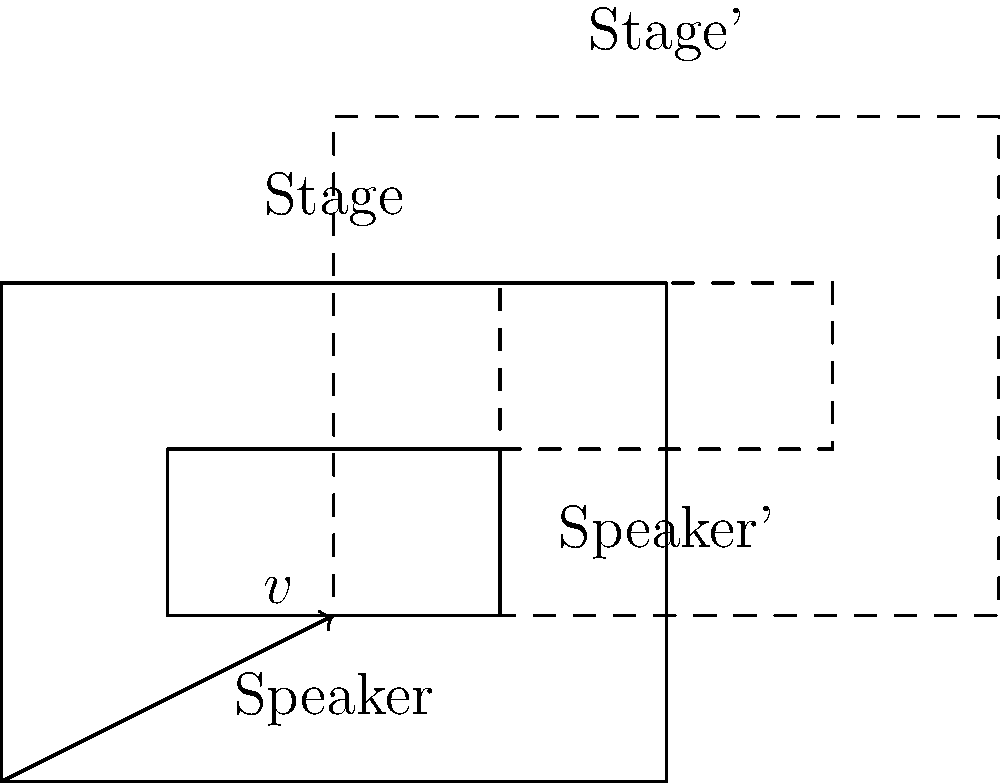As part of your upcoming performance, you need to adjust the stage setup. The diagram shows the current positions of the stage and speaker. If you need to translate the entire setup by vector $v = \langle 2, 1 \rangle$, what will be the new coordinates of point G (top-right corner of the speaker) after the translation? To find the new coordinates of point G after translation, we follow these steps:

1. Identify the original coordinates of point G:
   G is at (3, 2) in the original setup.

2. Understand the translation vector:
   $v = \langle 2, 1 \rangle$ means we need to add 2 to the x-coordinate and 1 to the y-coordinate.

3. Apply the translation:
   - New x-coordinate: $3 + 2 = 5$
   - New y-coordinate: $2 + 1 = 3$

4. Express the new position:
   After translation, G' will be at (5, 3).

The new coordinates of point G can be mathematically expressed as:
$$G' = G + v = (3, 2) + \langle 2, 1 \rangle = (5, 3)$$
Answer: (5, 3) 